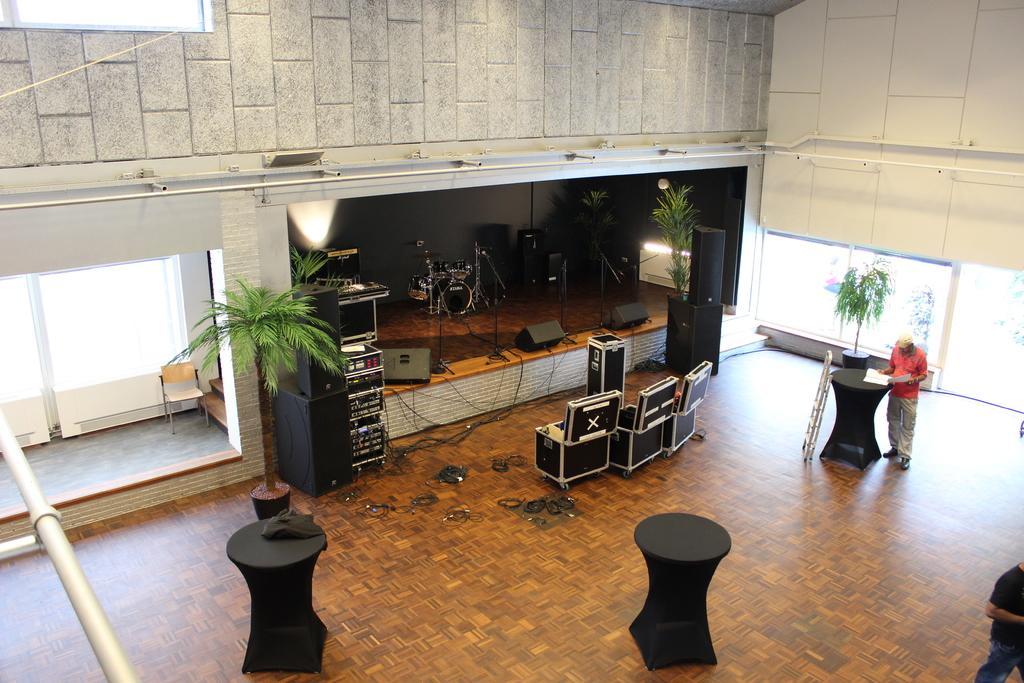Can you describe this image briefly? This is an inside view picture of a building. We can see musical instruments, speakers and few objects on a platform. In this picture we can see plants, few objects, floor, ladder, tables, pots. We can see a person is standing near a table and he is holding a paper. On the table we can see a paper. We can see a chair, glass walls. On the right side of the picture we can see the partial part of a person. 